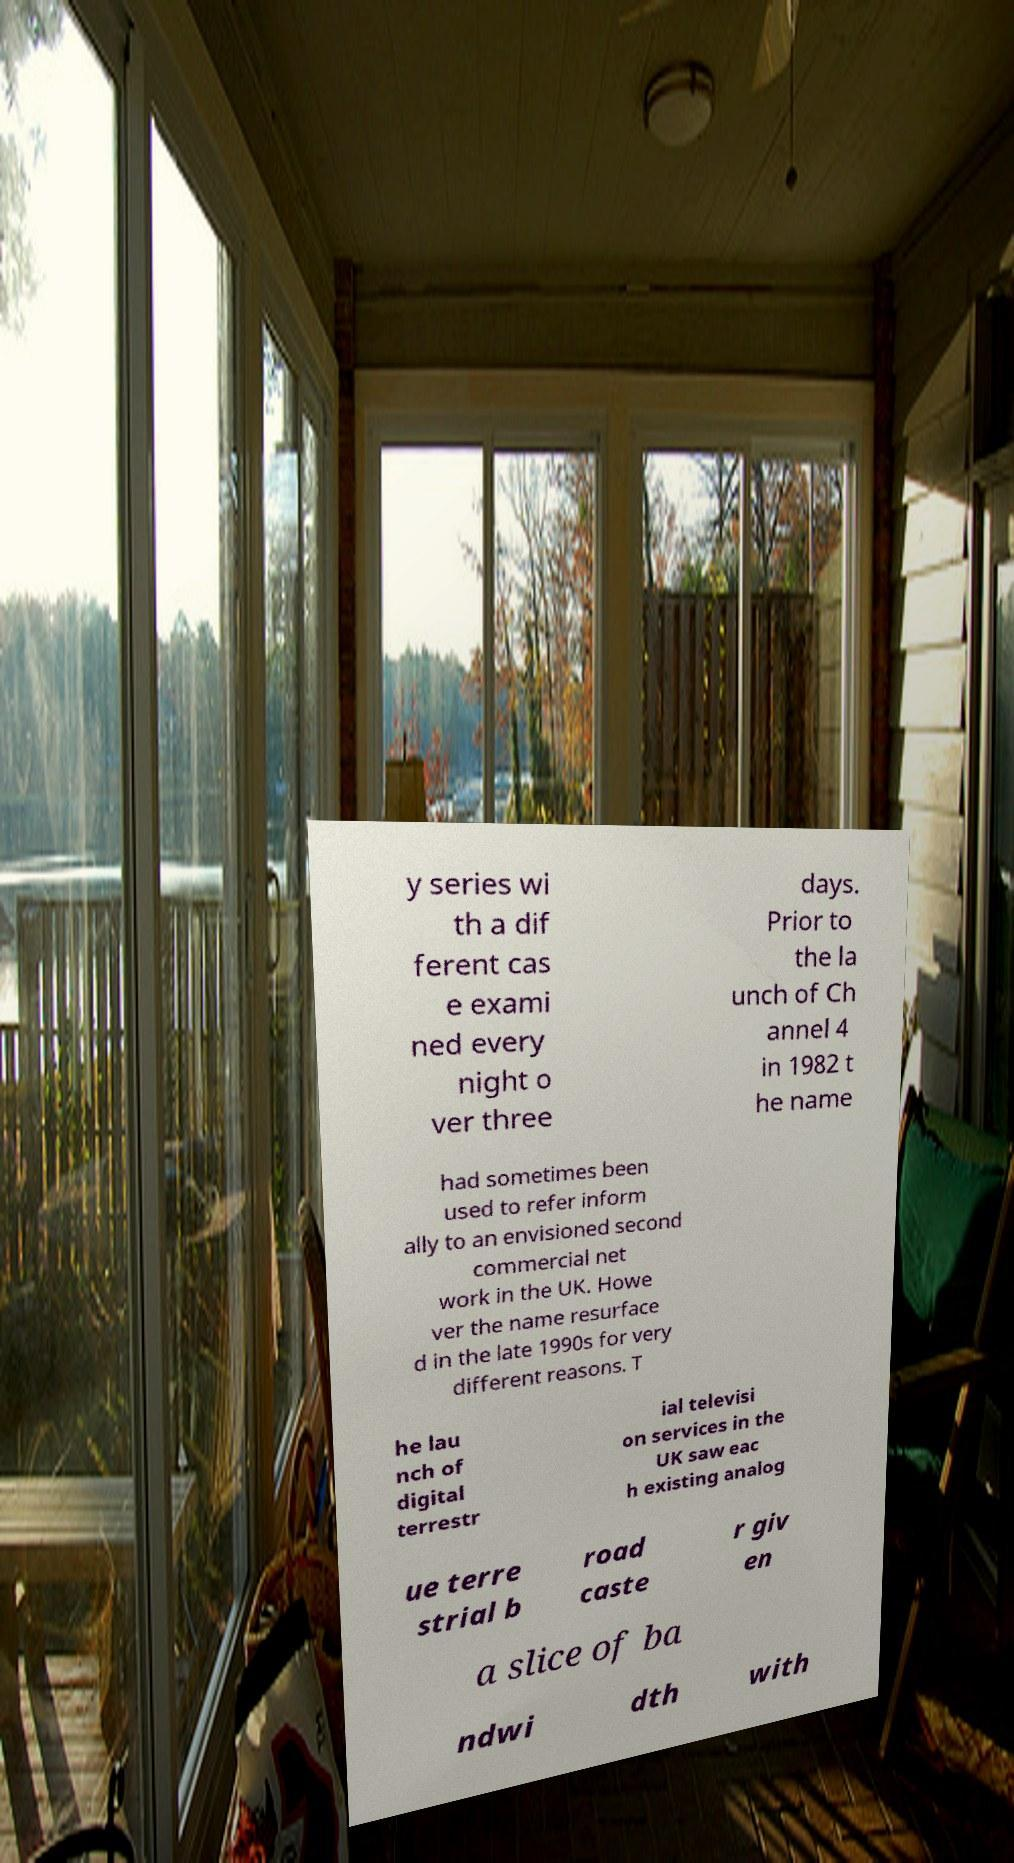I need the written content from this picture converted into text. Can you do that? y series wi th a dif ferent cas e exami ned every night o ver three days. Prior to the la unch of Ch annel 4 in 1982 t he name had sometimes been used to refer inform ally to an envisioned second commercial net work in the UK. Howe ver the name resurface d in the late 1990s for very different reasons. T he lau nch of digital terrestr ial televisi on services in the UK saw eac h existing analog ue terre strial b road caste r giv en a slice of ba ndwi dth with 